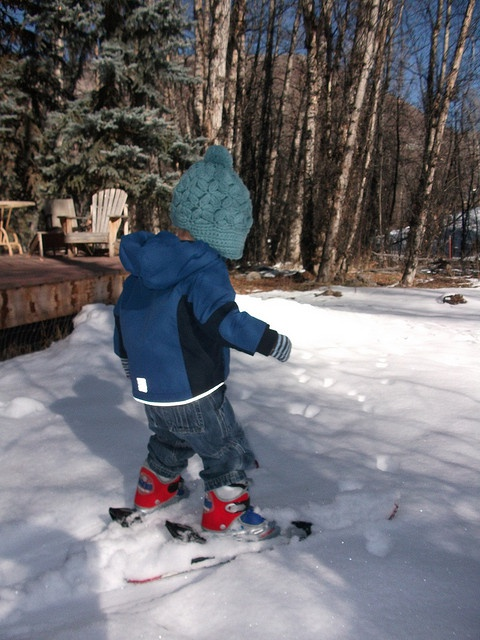Describe the objects in this image and their specific colors. I can see people in black, navy, blue, and gray tones, skis in black, darkgray, lightgray, and gray tones, chair in black, tan, darkgray, and gray tones, chair in black, tan, and gray tones, and dining table in black, tan, and gray tones in this image. 